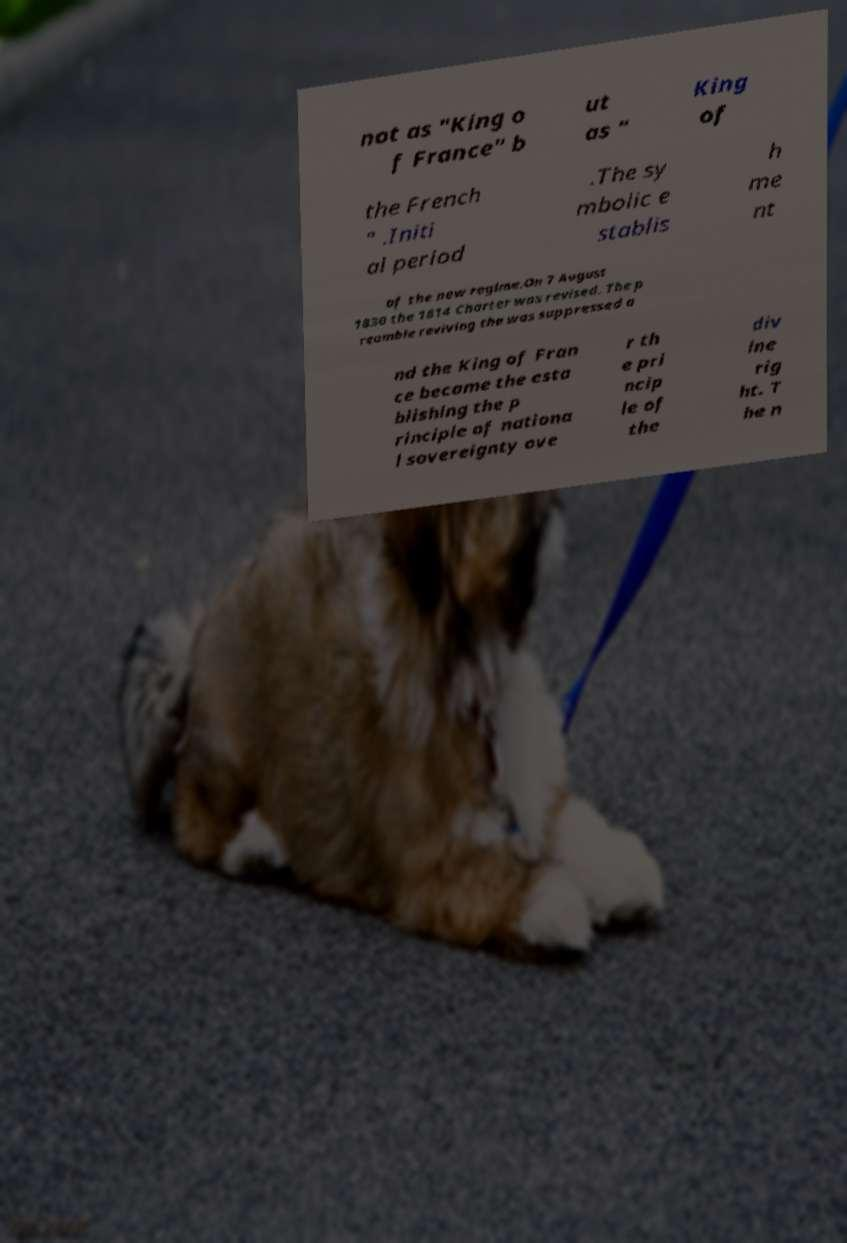For documentation purposes, I need the text within this image transcribed. Could you provide that? not as "King o f France" b ut as " King of the French " .Initi al period .The sy mbolic e stablis h me nt of the new regime.On 7 August 1830 the 1814 Charter was revised. The p reamble reviving the was suppressed a nd the King of Fran ce became the esta blishing the p rinciple of nationa l sovereignty ove r th e pri ncip le of the div ine rig ht. T he n 